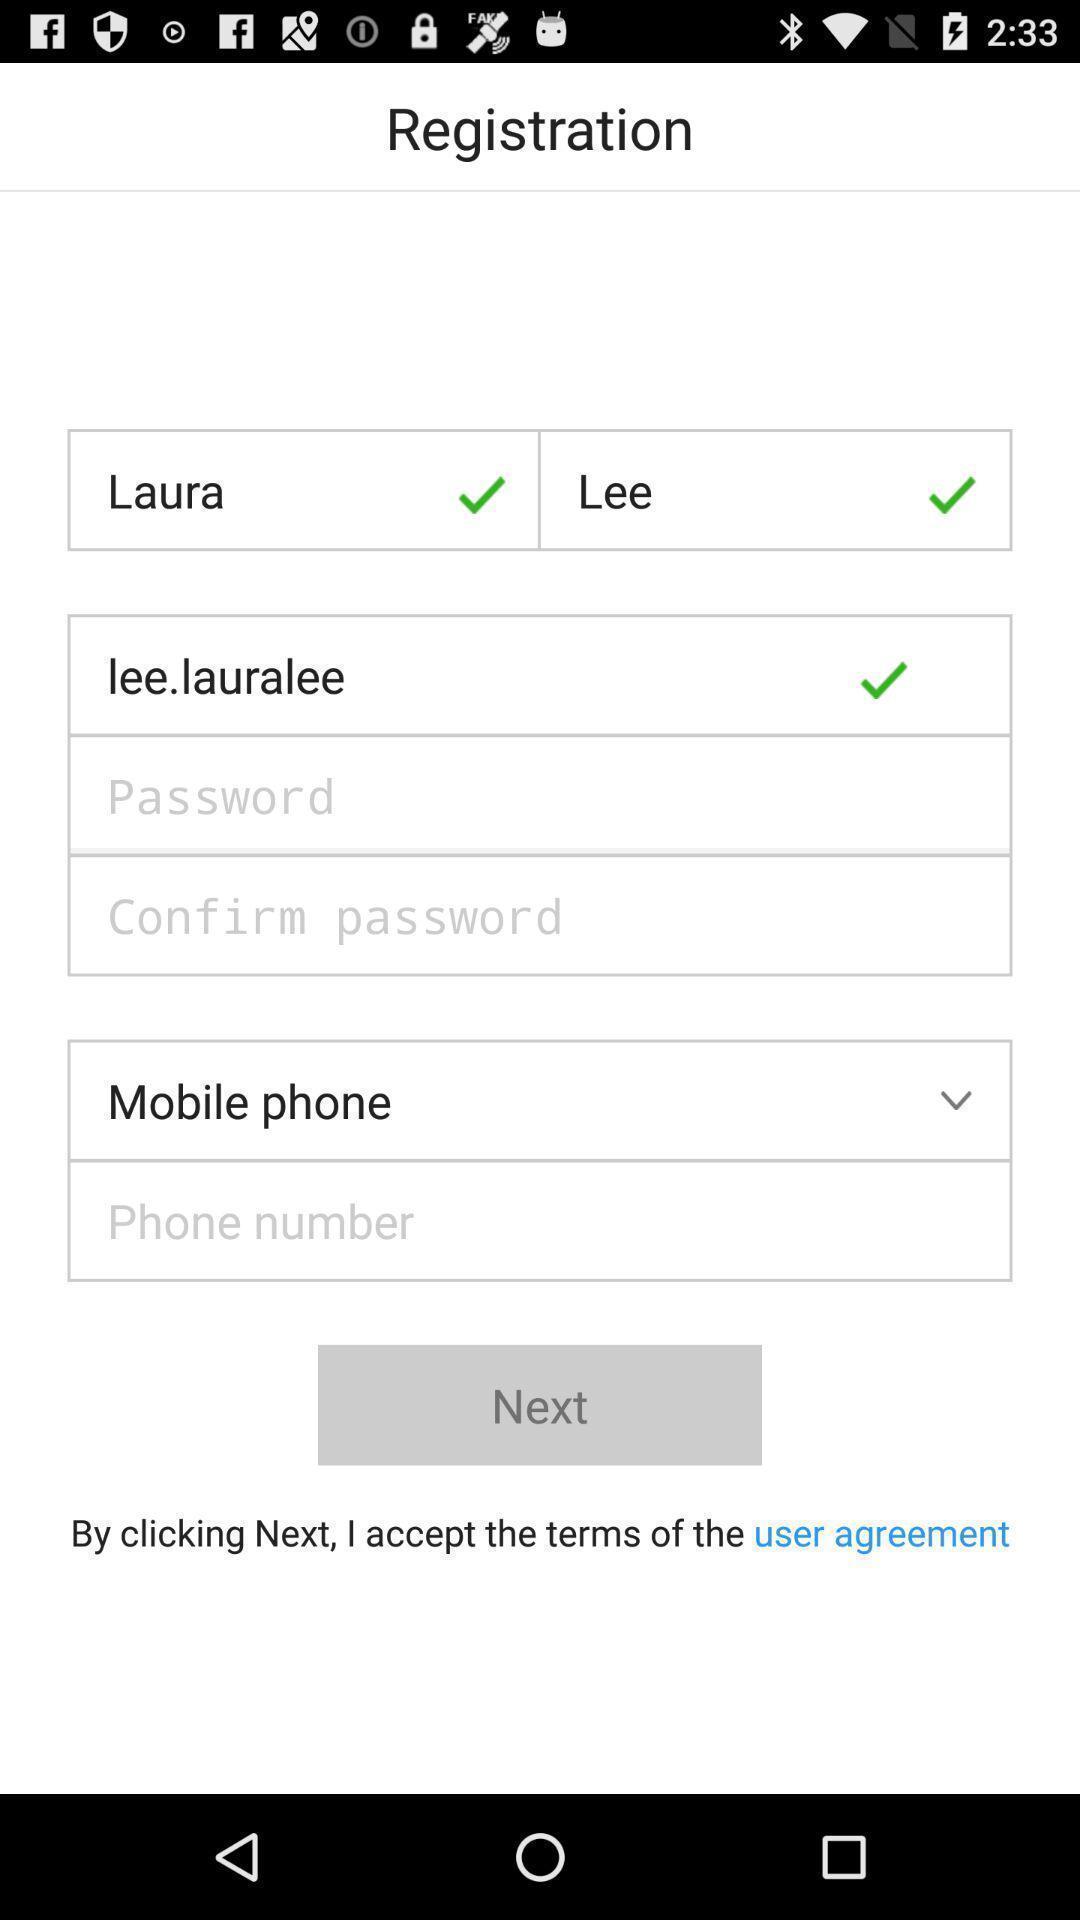Tell me what you see in this picture. Screen displaying contents in registration page. 